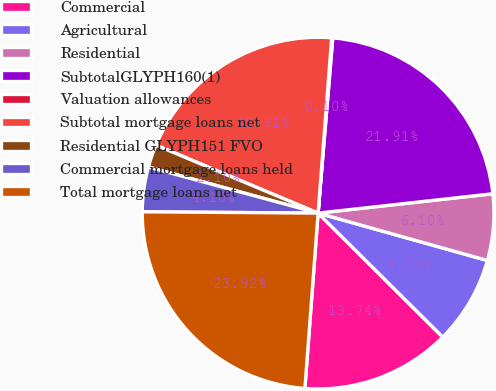Convert chart. <chart><loc_0><loc_0><loc_500><loc_500><pie_chart><fcel>Commercial<fcel>Agricultural<fcel>Residential<fcel>SubtotalGLYPH160(1)<fcel>Valuation allowances<fcel>Subtotal mortgage loans net<fcel>Residential GLYPH151 FVO<fcel>Commercial mortgage loans held<fcel>Total mortgage loans net<nl><fcel>13.74%<fcel>8.11%<fcel>6.1%<fcel>21.91%<fcel>0.1%<fcel>19.91%<fcel>2.1%<fcel>4.1%<fcel>23.92%<nl></chart> 